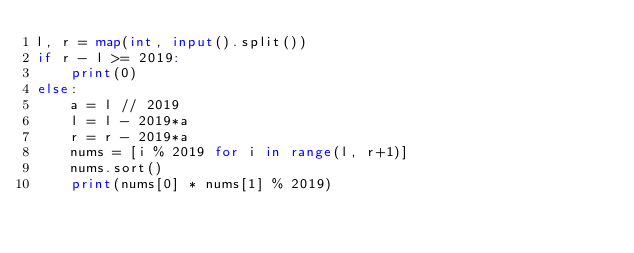Convert code to text. <code><loc_0><loc_0><loc_500><loc_500><_Python_>l, r = map(int, input().split())
if r - l >= 2019:
    print(0)
else:
    a = l // 2019
    l = l - 2019*a
    r = r - 2019*a
    nums = [i % 2019 for i in range(l, r+1)]
    nums.sort()
    print(nums[0] * nums[1] % 2019)</code> 